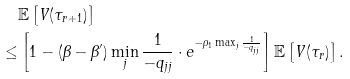<formula> <loc_0><loc_0><loc_500><loc_500>& \mathbb { E } \left [ V ( \tau _ { r + 1 } ) \right ] \\ \leq & \left [ 1 - ( \beta - \beta ^ { \prime } ) \min _ { j } \frac { 1 } { - q _ { j j } } \cdot e ^ { - \rho _ { 1 } \max _ { j } \frac { 1 } { - q _ { j j } } } \right ] \mathbb { E } \left [ V ( \tau _ { r } ) \right ] .</formula> 